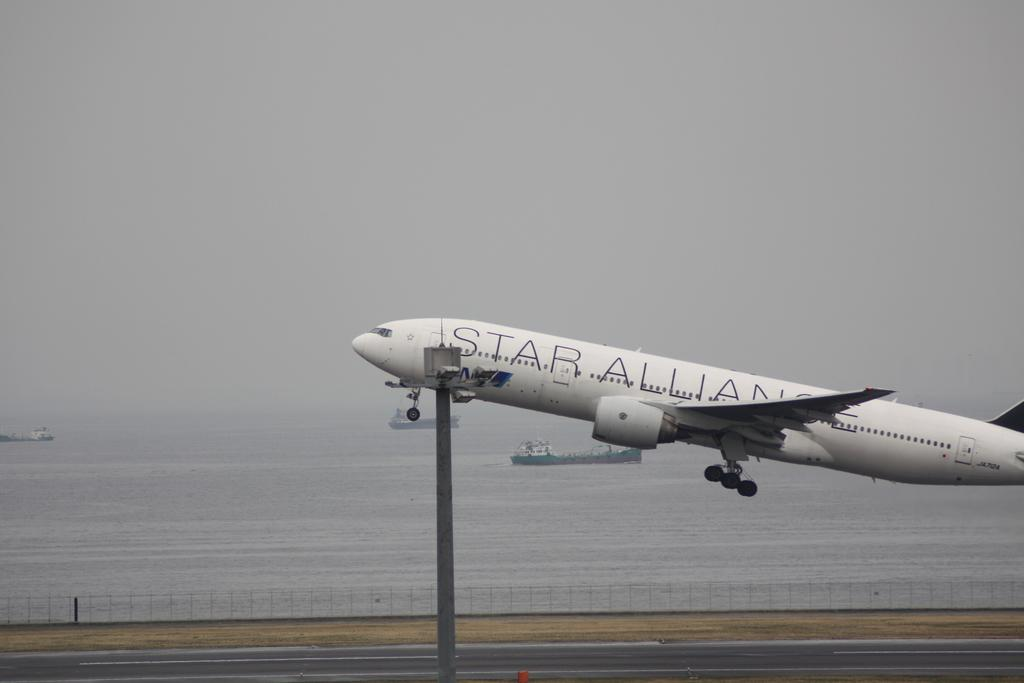<image>
Give a short and clear explanation of the subsequent image. A white airplane with the words Star Alliance on the side taking off 